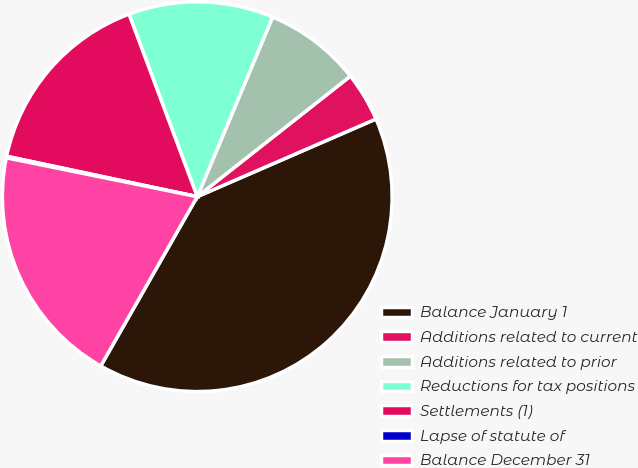Convert chart to OTSL. <chart><loc_0><loc_0><loc_500><loc_500><pie_chart><fcel>Balance January 1<fcel>Additions related to current<fcel>Additions related to prior<fcel>Reductions for tax positions<fcel>Settlements (1)<fcel>Lapse of statute of<fcel>Balance December 31<nl><fcel>39.77%<fcel>4.09%<fcel>8.06%<fcel>12.02%<fcel>15.98%<fcel>0.13%<fcel>19.95%<nl></chart> 